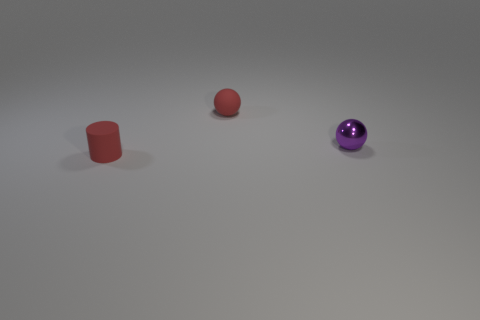What material is the tiny cylinder? Based on the image, the tiny cylinder appears to have a smooth and matte finish which is often characteristic of objects made from plastic materials. Its appearance doesn't show the reflective sheen that's typically associated with metallic surfaces, nor does it have the textured surface that might suggest a material like rubber. Therefore, a more accurate guess would be that the tiny cylinder is likely made of plastic. 